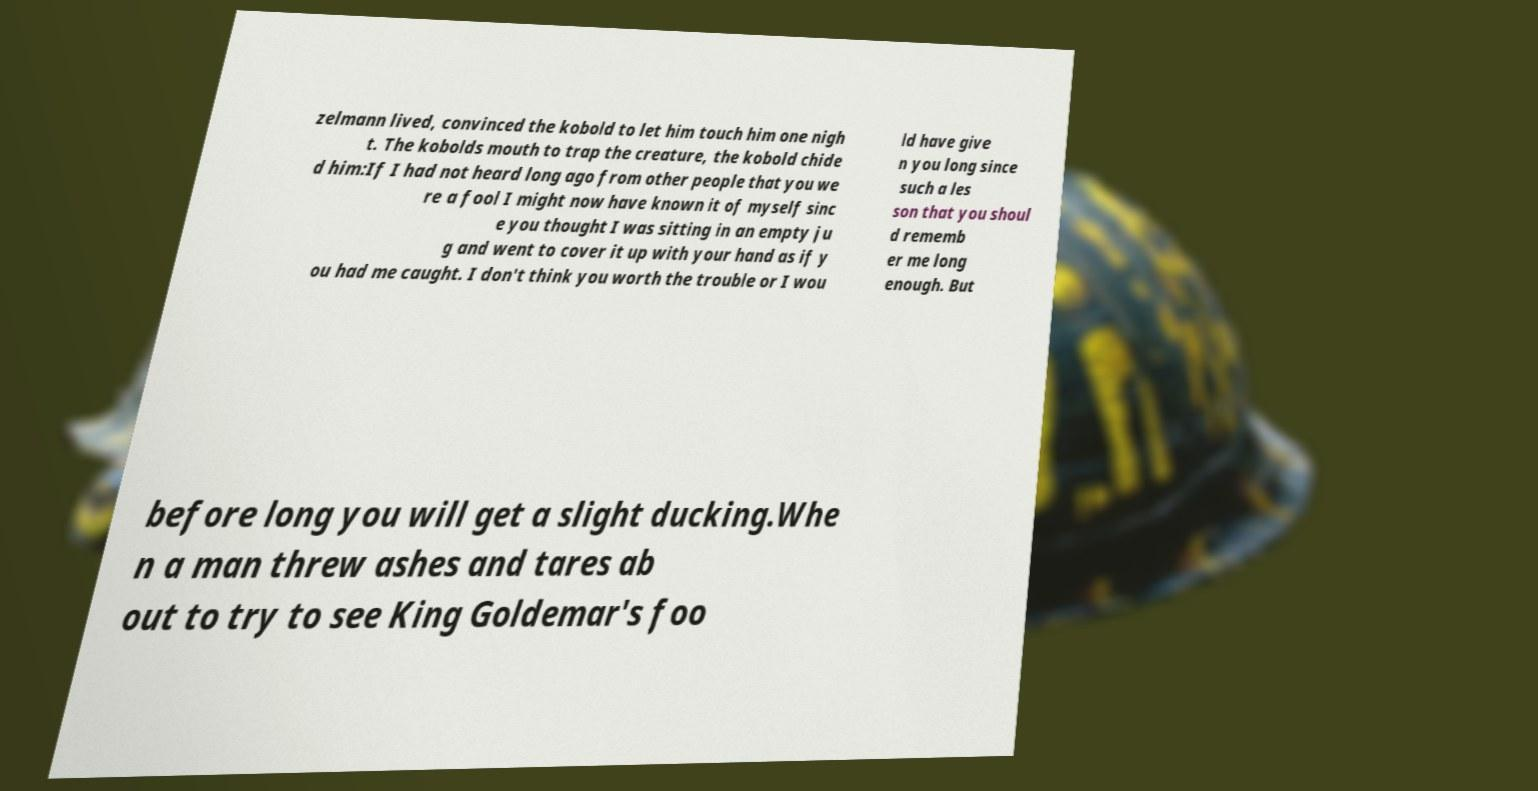Can you accurately transcribe the text from the provided image for me? zelmann lived, convinced the kobold to let him touch him one nigh t. The kobolds mouth to trap the creature, the kobold chide d him:If I had not heard long ago from other people that you we re a fool I might now have known it of myself sinc e you thought I was sitting in an empty ju g and went to cover it up with your hand as if y ou had me caught. I don't think you worth the trouble or I wou ld have give n you long since such a les son that you shoul d rememb er me long enough. But before long you will get a slight ducking.Whe n a man threw ashes and tares ab out to try to see King Goldemar's foo 